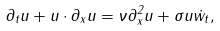<formula> <loc_0><loc_0><loc_500><loc_500>\partial _ { t } u + u \cdot \partial _ { x } u = \nu \partial _ { x } ^ { 2 } u + \sigma u \dot { w } _ { t } ,</formula> 